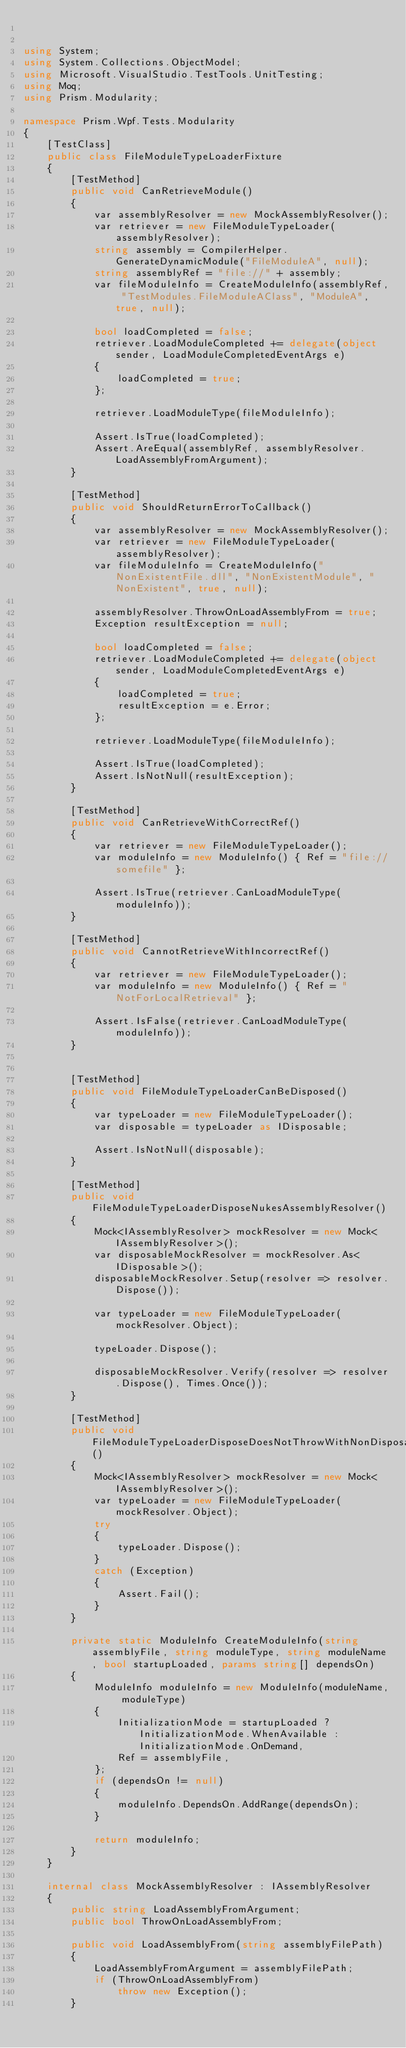<code> <loc_0><loc_0><loc_500><loc_500><_C#_>

using System;
using System.Collections.ObjectModel;
using Microsoft.VisualStudio.TestTools.UnitTesting;
using Moq;
using Prism.Modularity;

namespace Prism.Wpf.Tests.Modularity
{
    [TestClass]
    public class FileModuleTypeLoaderFixture
    {
        [TestMethod]
        public void CanRetrieveModule()
        {
            var assemblyResolver = new MockAssemblyResolver();
            var retriever = new FileModuleTypeLoader(assemblyResolver);
            string assembly = CompilerHelper.GenerateDynamicModule("FileModuleA", null);
            string assemblyRef = "file://" + assembly;
            var fileModuleInfo = CreateModuleInfo(assemblyRef, "TestModules.FileModuleAClass", "ModuleA", true, null);

            bool loadCompleted = false;
            retriever.LoadModuleCompleted += delegate(object sender, LoadModuleCompletedEventArgs e)
            {
                loadCompleted = true;
            };

            retriever.LoadModuleType(fileModuleInfo);

            Assert.IsTrue(loadCompleted);
            Assert.AreEqual(assemblyRef, assemblyResolver.LoadAssemblyFromArgument);
        }

        [TestMethod]
        public void ShouldReturnErrorToCallback()
        {
            var assemblyResolver = new MockAssemblyResolver();
            var retriever = new FileModuleTypeLoader(assemblyResolver);
            var fileModuleInfo = CreateModuleInfo("NonExistentFile.dll", "NonExistentModule", "NonExistent", true, null);

            assemblyResolver.ThrowOnLoadAssemblyFrom = true;
            Exception resultException = null;

            bool loadCompleted = false;
            retriever.LoadModuleCompleted += delegate(object sender, LoadModuleCompletedEventArgs e)
            {
                loadCompleted = true;
                resultException = e.Error;
            };

            retriever.LoadModuleType(fileModuleInfo);

            Assert.IsTrue(loadCompleted);
            Assert.IsNotNull(resultException);
        }

        [TestMethod]
        public void CanRetrieveWithCorrectRef()
        {
            var retriever = new FileModuleTypeLoader();
            var moduleInfo = new ModuleInfo() { Ref = "file://somefile" };

            Assert.IsTrue(retriever.CanLoadModuleType(moduleInfo));
        }

        [TestMethod]
        public void CannotRetrieveWithIncorrectRef()
        {
            var retriever = new FileModuleTypeLoader();
            var moduleInfo = new ModuleInfo() { Ref = "NotForLocalRetrieval" };

            Assert.IsFalse(retriever.CanLoadModuleType(moduleInfo));
        }

        
        [TestMethod]
        public void FileModuleTypeLoaderCanBeDisposed()
        {
            var typeLoader = new FileModuleTypeLoader();
            var disposable = typeLoader as IDisposable;

            Assert.IsNotNull(disposable);
        }

        [TestMethod]
        public void FileModuleTypeLoaderDisposeNukesAssemblyResolver()
        {
            Mock<IAssemblyResolver> mockResolver = new Mock<IAssemblyResolver>();
            var disposableMockResolver = mockResolver.As<IDisposable>();
            disposableMockResolver.Setup(resolver => resolver.Dispose());

            var typeLoader = new FileModuleTypeLoader(mockResolver.Object);
            
            typeLoader.Dispose();

            disposableMockResolver.Verify(resolver => resolver.Dispose(), Times.Once());
        }

        [TestMethod]
        public void FileModuleTypeLoaderDisposeDoesNotThrowWithNonDisposableAssemblyResolver()
        {
            Mock<IAssemblyResolver> mockResolver = new Mock<IAssemblyResolver>();
            var typeLoader = new FileModuleTypeLoader(mockResolver.Object);
            try
            {
                typeLoader.Dispose();
            }
            catch (Exception)
            {
                Assert.Fail();
            }
        }

        private static ModuleInfo CreateModuleInfo(string assemblyFile, string moduleType, string moduleName, bool startupLoaded, params string[] dependsOn)
        {
            ModuleInfo moduleInfo = new ModuleInfo(moduleName, moduleType)
            {
                InitializationMode = startupLoaded ? InitializationMode.WhenAvailable : InitializationMode.OnDemand,
                Ref = assemblyFile,
            };
            if (dependsOn != null)
            {
                moduleInfo.DependsOn.AddRange(dependsOn);
            }

            return moduleInfo;
        }
    }

    internal class MockAssemblyResolver : IAssemblyResolver
    {
        public string LoadAssemblyFromArgument;
        public bool ThrowOnLoadAssemblyFrom;

        public void LoadAssemblyFrom(string assemblyFilePath)
        {
            LoadAssemblyFromArgument = assemblyFilePath;
            if (ThrowOnLoadAssemblyFrom)
                throw new Exception();
        }</code> 